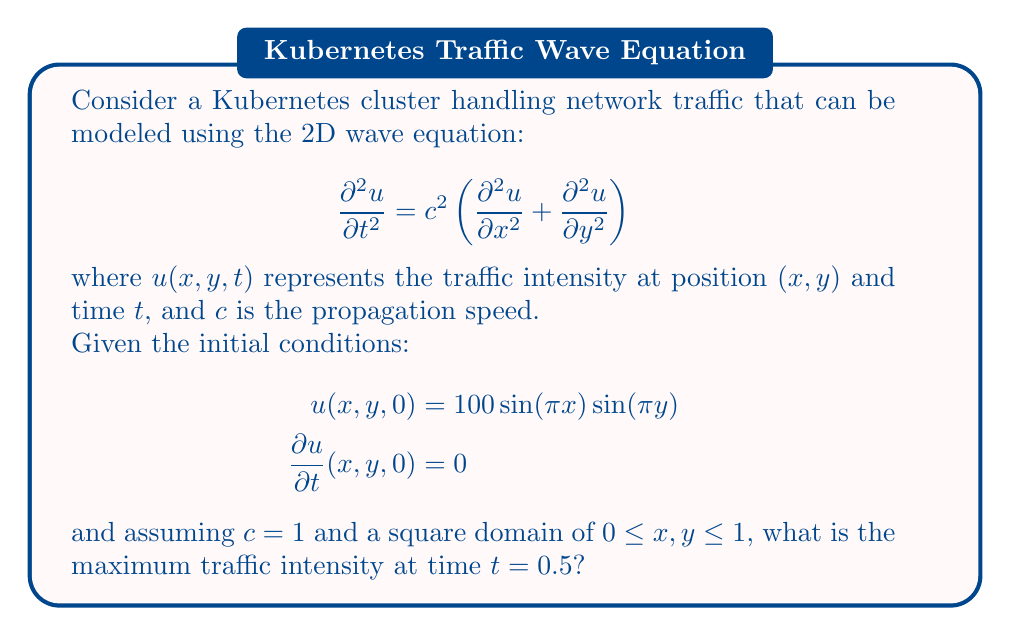Provide a solution to this math problem. To solve this problem, we'll follow these steps:

1) The general solution to the 2D wave equation with the given initial conditions is:

   $$ u(x,y,t) = A \cos(\omega t) \sin(\pi x) \sin(\pi y) $$

   where $A$ is the amplitude and $\omega$ is the angular frequency.

2) From the initial condition $u(x,y,0) = 100 \sin(\pi x) \sin(\pi y)$, we can determine that $A = 100$.

3) To find $\omega$, we use the relationship:

   $$ \omega^2 = c^2(\pi^2 + \pi^2) = 2c^2\pi^2 $$

   Since $c = 1$, we have $\omega = \sqrt{2}\pi$.

4) Therefore, our solution is:

   $$ u(x,y,t) = 100 \cos(\sqrt{2}\pi t) \sin(\pi x) \sin(\pi y) $$

5) At $t = 0.5$, the solution becomes:

   $$ u(x,y,0.5) = 100 \cos(\sqrt{2}\pi \cdot 0.5) \sin(\pi x) \sin(\pi y) $$

6) The maximum value will occur when $\sin(\pi x) = \sin(\pi y) = 1$, which happens at $(x,y) = (0.5,0.5)$.

7) Therefore, the maximum traffic intensity is:

   $$ u_{max} = 100 |\cos(\sqrt{2}\pi \cdot 0.5)| \approx 100 \cdot 0.2778 \approx 27.78 $$
Answer: 27.78 